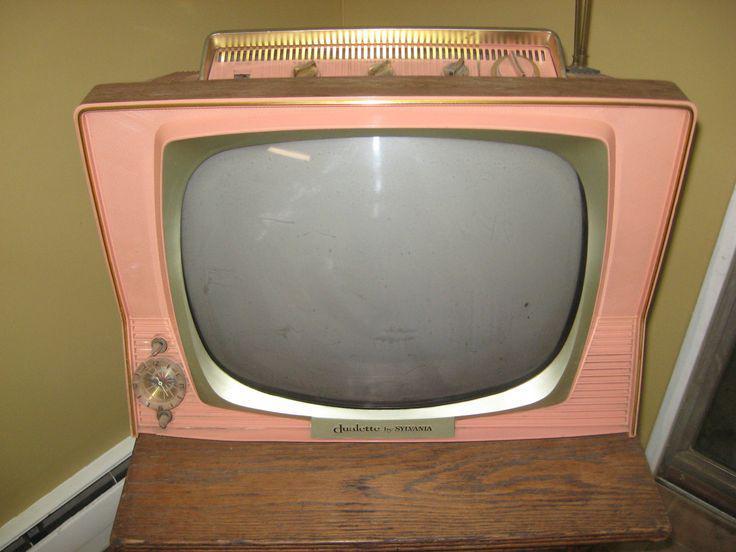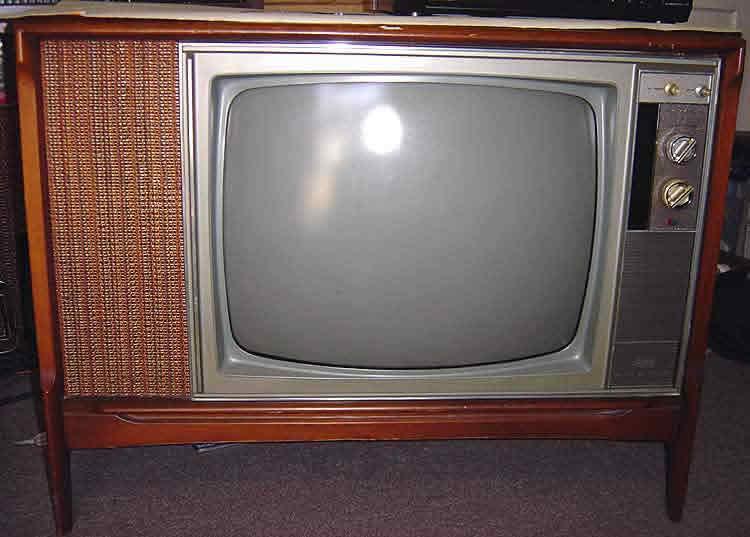The first image is the image on the left, the second image is the image on the right. Considering the images on both sides, is "One of the televisions has an underneath speaker." valid? Answer yes or no. No. The first image is the image on the left, the second image is the image on the right. Assess this claim about the two images: "The TV on the left is sitting on a wood surface, and the TV on the right is a console style with its screen in a wooden case with no panel under the screen and with slender legs.". Correct or not? Answer yes or no. Yes. 